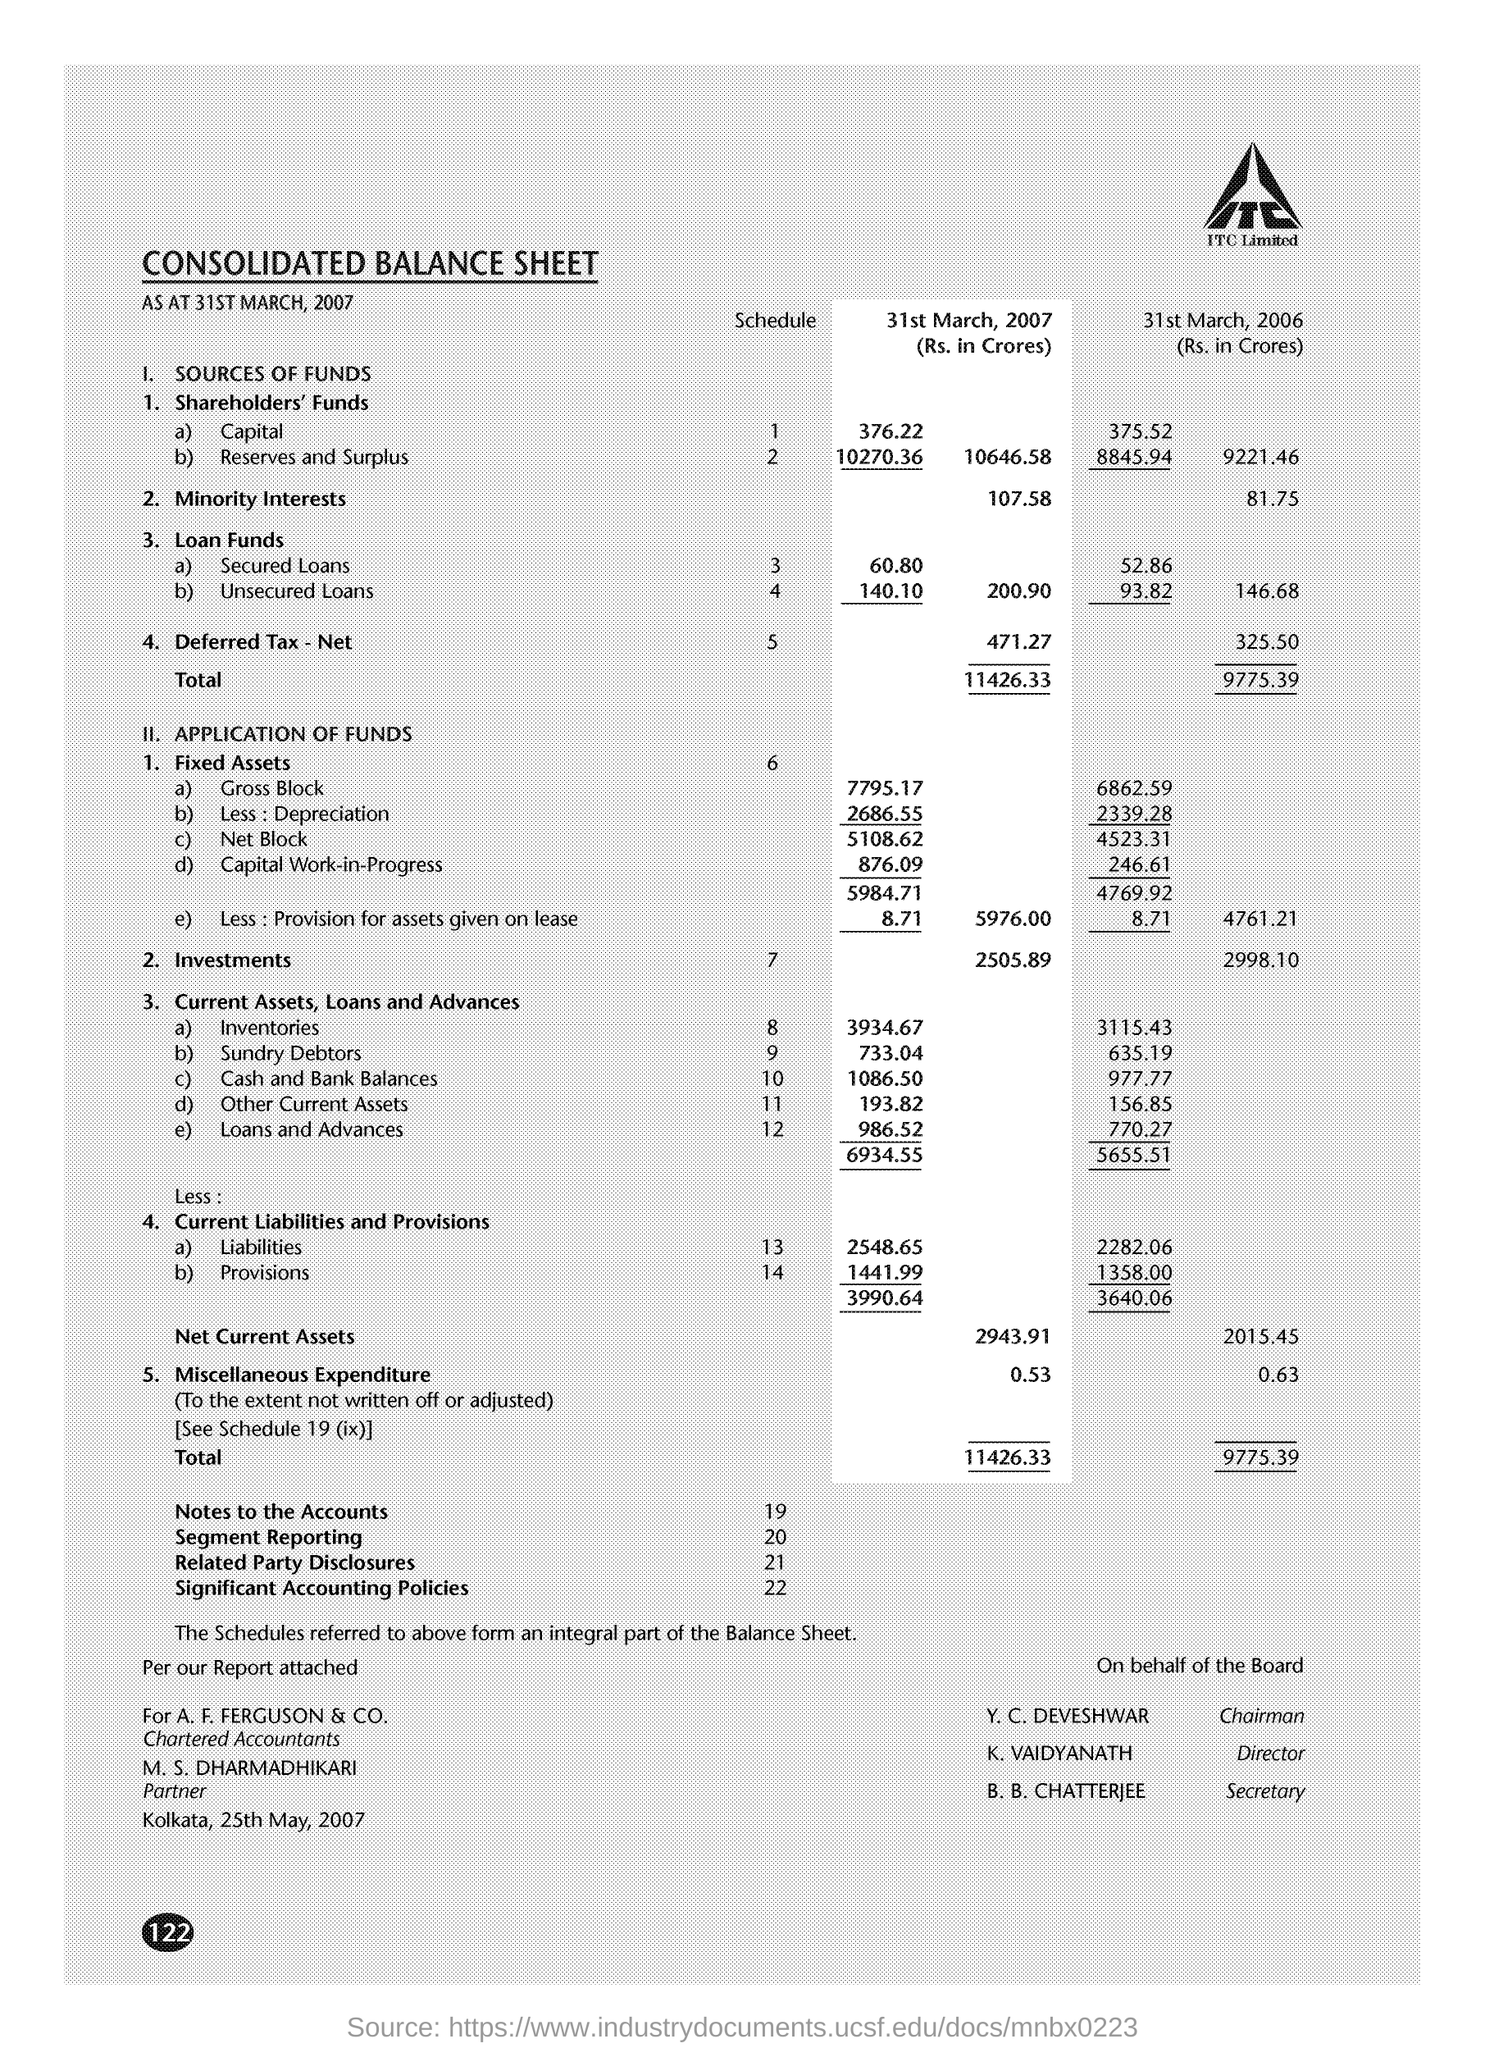How much did the 'Investments' value change over the one-year period ending 31st March 2007? The 'Investments' value decreased by ₹192.21 Crores, from ₹2998.10 Crores as of 31st March 2006 to ₹2505.89 Crores as of 31st March 2007. 